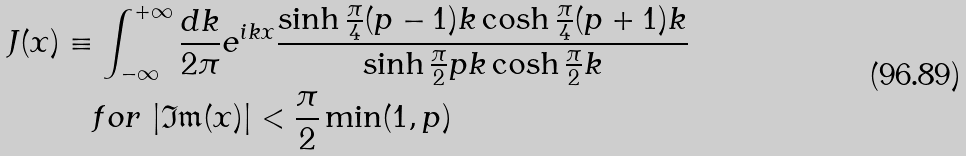Convert formula to latex. <formula><loc_0><loc_0><loc_500><loc_500>J ( x ) & \equiv \int _ { - \infty } ^ { + \infty } \frac { d k } { 2 \pi } e ^ { i k x } \frac { \sinh \frac { \pi } { 4 } ( p - 1 ) k \cosh \frac { \pi } { 4 } ( p + 1 ) k } { \sinh \frac { \pi } { 2 } p k \cosh \frac { \pi } { 2 } k } \quad \\ & \quad f o r \, \left | \mathfrak { I m } ( x ) \right | < \frac { \pi } { 2 } \min ( 1 , p )</formula> 